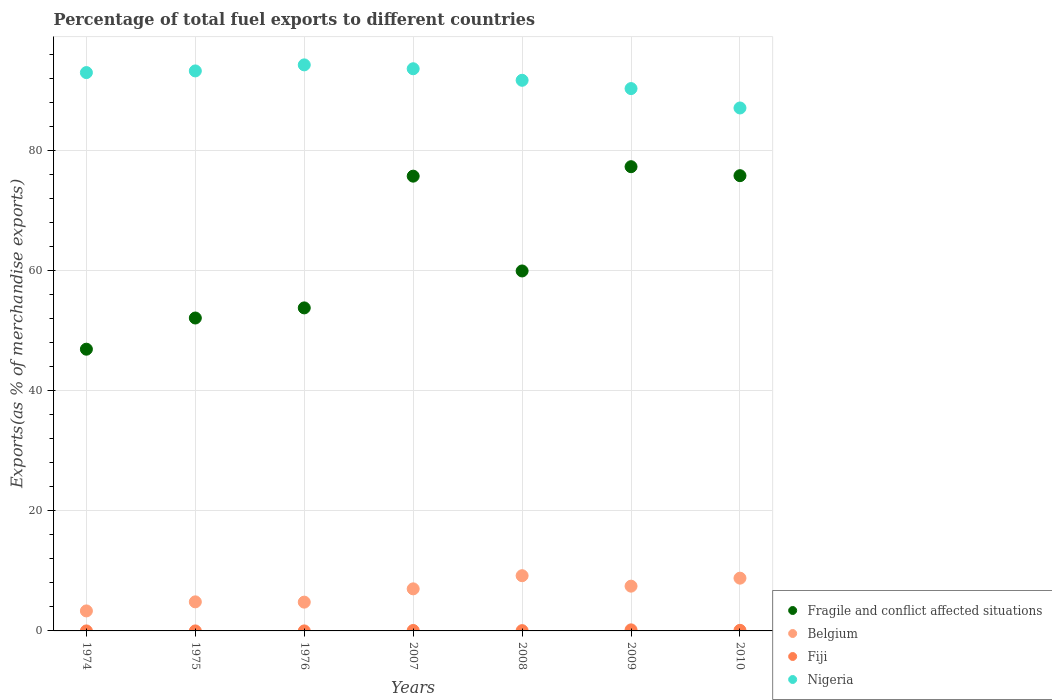How many different coloured dotlines are there?
Provide a short and direct response. 4. Is the number of dotlines equal to the number of legend labels?
Keep it short and to the point. Yes. What is the percentage of exports to different countries in Fragile and conflict affected situations in 2008?
Make the answer very short. 59.98. Across all years, what is the maximum percentage of exports to different countries in Nigeria?
Your response must be concise. 94.31. Across all years, what is the minimum percentage of exports to different countries in Belgium?
Provide a succinct answer. 3.33. In which year was the percentage of exports to different countries in Nigeria maximum?
Your response must be concise. 1976. In which year was the percentage of exports to different countries in Belgium minimum?
Ensure brevity in your answer.  1974. What is the total percentage of exports to different countries in Belgium in the graph?
Your answer should be compact. 45.43. What is the difference between the percentage of exports to different countries in Fiji in 2007 and that in 2008?
Your answer should be compact. 0.03. What is the difference between the percentage of exports to different countries in Fiji in 2007 and the percentage of exports to different countries in Nigeria in 1974?
Your answer should be very brief. -92.95. What is the average percentage of exports to different countries in Fragile and conflict affected situations per year?
Your answer should be compact. 63.12. In the year 2007, what is the difference between the percentage of exports to different countries in Fiji and percentage of exports to different countries in Belgium?
Keep it short and to the point. -6.93. What is the ratio of the percentage of exports to different countries in Nigeria in 1975 to that in 1976?
Provide a succinct answer. 0.99. Is the difference between the percentage of exports to different countries in Fiji in 1976 and 2009 greater than the difference between the percentage of exports to different countries in Belgium in 1976 and 2009?
Ensure brevity in your answer.  Yes. What is the difference between the highest and the second highest percentage of exports to different countries in Fragile and conflict affected situations?
Your answer should be very brief. 1.5. What is the difference between the highest and the lowest percentage of exports to different countries in Nigeria?
Offer a very short reply. 7.18. Is it the case that in every year, the sum of the percentage of exports to different countries in Fiji and percentage of exports to different countries in Belgium  is greater than the percentage of exports to different countries in Nigeria?
Your response must be concise. No. Does the percentage of exports to different countries in Fiji monotonically increase over the years?
Your response must be concise. No. Is the percentage of exports to different countries in Nigeria strictly greater than the percentage of exports to different countries in Fiji over the years?
Your response must be concise. Yes. How many dotlines are there?
Provide a succinct answer. 4. How many years are there in the graph?
Provide a short and direct response. 7. What is the difference between two consecutive major ticks on the Y-axis?
Your answer should be compact. 20. Are the values on the major ticks of Y-axis written in scientific E-notation?
Keep it short and to the point. No. Does the graph contain grids?
Ensure brevity in your answer.  Yes. What is the title of the graph?
Provide a short and direct response. Percentage of total fuel exports to different countries. What is the label or title of the Y-axis?
Your answer should be very brief. Exports(as % of merchandise exports). What is the Exports(as % of merchandise exports) in Fragile and conflict affected situations in 1974?
Your response must be concise. 46.94. What is the Exports(as % of merchandise exports) in Belgium in 1974?
Offer a terse response. 3.33. What is the Exports(as % of merchandise exports) in Fiji in 1974?
Your answer should be very brief. 0. What is the Exports(as % of merchandise exports) in Nigeria in 1974?
Keep it short and to the point. 93.03. What is the Exports(as % of merchandise exports) of Fragile and conflict affected situations in 1975?
Give a very brief answer. 52.14. What is the Exports(as % of merchandise exports) in Belgium in 1975?
Make the answer very short. 4.84. What is the Exports(as % of merchandise exports) of Fiji in 1975?
Provide a short and direct response. 4.37885188442796e-5. What is the Exports(as % of merchandise exports) in Nigeria in 1975?
Your answer should be compact. 93.3. What is the Exports(as % of merchandise exports) of Fragile and conflict affected situations in 1976?
Provide a short and direct response. 53.82. What is the Exports(as % of merchandise exports) of Belgium in 1976?
Your response must be concise. 4.8. What is the Exports(as % of merchandise exports) in Fiji in 1976?
Offer a terse response. 0. What is the Exports(as % of merchandise exports) in Nigeria in 1976?
Provide a short and direct response. 94.31. What is the Exports(as % of merchandise exports) of Fragile and conflict affected situations in 2007?
Keep it short and to the point. 75.77. What is the Exports(as % of merchandise exports) in Belgium in 2007?
Ensure brevity in your answer.  7.01. What is the Exports(as % of merchandise exports) of Fiji in 2007?
Keep it short and to the point. 0.08. What is the Exports(as % of merchandise exports) of Nigeria in 2007?
Offer a terse response. 93.67. What is the Exports(as % of merchandise exports) of Fragile and conflict affected situations in 2008?
Ensure brevity in your answer.  59.98. What is the Exports(as % of merchandise exports) in Belgium in 2008?
Ensure brevity in your answer.  9.2. What is the Exports(as % of merchandise exports) of Fiji in 2008?
Your answer should be very brief. 0.05. What is the Exports(as % of merchandise exports) in Nigeria in 2008?
Your answer should be compact. 91.74. What is the Exports(as % of merchandise exports) in Fragile and conflict affected situations in 2009?
Make the answer very short. 77.35. What is the Exports(as % of merchandise exports) in Belgium in 2009?
Give a very brief answer. 7.46. What is the Exports(as % of merchandise exports) of Fiji in 2009?
Your answer should be compact. 0.18. What is the Exports(as % of merchandise exports) of Nigeria in 2009?
Make the answer very short. 90.36. What is the Exports(as % of merchandise exports) in Fragile and conflict affected situations in 2010?
Your response must be concise. 75.85. What is the Exports(as % of merchandise exports) in Belgium in 2010?
Make the answer very short. 8.79. What is the Exports(as % of merchandise exports) in Fiji in 2010?
Provide a short and direct response. 0.1. What is the Exports(as % of merchandise exports) of Nigeria in 2010?
Give a very brief answer. 87.13. Across all years, what is the maximum Exports(as % of merchandise exports) in Fragile and conflict affected situations?
Offer a very short reply. 77.35. Across all years, what is the maximum Exports(as % of merchandise exports) of Belgium?
Keep it short and to the point. 9.2. Across all years, what is the maximum Exports(as % of merchandise exports) in Fiji?
Offer a terse response. 0.18. Across all years, what is the maximum Exports(as % of merchandise exports) of Nigeria?
Offer a very short reply. 94.31. Across all years, what is the minimum Exports(as % of merchandise exports) in Fragile and conflict affected situations?
Give a very brief answer. 46.94. Across all years, what is the minimum Exports(as % of merchandise exports) in Belgium?
Keep it short and to the point. 3.33. Across all years, what is the minimum Exports(as % of merchandise exports) in Fiji?
Offer a very short reply. 4.37885188442796e-5. Across all years, what is the minimum Exports(as % of merchandise exports) in Nigeria?
Make the answer very short. 87.13. What is the total Exports(as % of merchandise exports) in Fragile and conflict affected situations in the graph?
Provide a succinct answer. 441.84. What is the total Exports(as % of merchandise exports) of Belgium in the graph?
Make the answer very short. 45.43. What is the total Exports(as % of merchandise exports) in Fiji in the graph?
Provide a short and direct response. 0.4. What is the total Exports(as % of merchandise exports) of Nigeria in the graph?
Give a very brief answer. 643.55. What is the difference between the Exports(as % of merchandise exports) of Fragile and conflict affected situations in 1974 and that in 1975?
Your answer should be compact. -5.2. What is the difference between the Exports(as % of merchandise exports) in Belgium in 1974 and that in 1975?
Provide a succinct answer. -1.51. What is the difference between the Exports(as % of merchandise exports) of Fiji in 1974 and that in 1975?
Make the answer very short. 0. What is the difference between the Exports(as % of merchandise exports) of Nigeria in 1974 and that in 1975?
Keep it short and to the point. -0.28. What is the difference between the Exports(as % of merchandise exports) in Fragile and conflict affected situations in 1974 and that in 1976?
Keep it short and to the point. -6.88. What is the difference between the Exports(as % of merchandise exports) in Belgium in 1974 and that in 1976?
Offer a very short reply. -1.46. What is the difference between the Exports(as % of merchandise exports) of Nigeria in 1974 and that in 1976?
Offer a very short reply. -1.28. What is the difference between the Exports(as % of merchandise exports) of Fragile and conflict affected situations in 1974 and that in 2007?
Ensure brevity in your answer.  -28.83. What is the difference between the Exports(as % of merchandise exports) in Belgium in 1974 and that in 2007?
Your answer should be compact. -3.68. What is the difference between the Exports(as % of merchandise exports) of Fiji in 1974 and that in 2007?
Provide a succinct answer. -0.07. What is the difference between the Exports(as % of merchandise exports) of Nigeria in 1974 and that in 2007?
Provide a short and direct response. -0.64. What is the difference between the Exports(as % of merchandise exports) in Fragile and conflict affected situations in 1974 and that in 2008?
Offer a very short reply. -13.04. What is the difference between the Exports(as % of merchandise exports) of Belgium in 1974 and that in 2008?
Your response must be concise. -5.87. What is the difference between the Exports(as % of merchandise exports) of Fiji in 1974 and that in 2008?
Ensure brevity in your answer.  -0.05. What is the difference between the Exports(as % of merchandise exports) in Nigeria in 1974 and that in 2008?
Your answer should be compact. 1.28. What is the difference between the Exports(as % of merchandise exports) of Fragile and conflict affected situations in 1974 and that in 2009?
Your answer should be compact. -30.41. What is the difference between the Exports(as % of merchandise exports) of Belgium in 1974 and that in 2009?
Your response must be concise. -4.12. What is the difference between the Exports(as % of merchandise exports) of Fiji in 1974 and that in 2009?
Your answer should be compact. -0.18. What is the difference between the Exports(as % of merchandise exports) in Nigeria in 1974 and that in 2009?
Make the answer very short. 2.66. What is the difference between the Exports(as % of merchandise exports) of Fragile and conflict affected situations in 1974 and that in 2010?
Provide a succinct answer. -28.91. What is the difference between the Exports(as % of merchandise exports) of Belgium in 1974 and that in 2010?
Give a very brief answer. -5.46. What is the difference between the Exports(as % of merchandise exports) in Fiji in 1974 and that in 2010?
Your answer should be compact. -0.1. What is the difference between the Exports(as % of merchandise exports) of Nigeria in 1974 and that in 2010?
Your answer should be compact. 5.89. What is the difference between the Exports(as % of merchandise exports) of Fragile and conflict affected situations in 1975 and that in 1976?
Offer a terse response. -1.68. What is the difference between the Exports(as % of merchandise exports) of Belgium in 1975 and that in 1976?
Provide a short and direct response. 0.05. What is the difference between the Exports(as % of merchandise exports) of Fiji in 1975 and that in 1976?
Your response must be concise. -0. What is the difference between the Exports(as % of merchandise exports) in Nigeria in 1975 and that in 1976?
Your answer should be very brief. -1.01. What is the difference between the Exports(as % of merchandise exports) in Fragile and conflict affected situations in 1975 and that in 2007?
Ensure brevity in your answer.  -23.63. What is the difference between the Exports(as % of merchandise exports) of Belgium in 1975 and that in 2007?
Your response must be concise. -2.17. What is the difference between the Exports(as % of merchandise exports) in Fiji in 1975 and that in 2007?
Your response must be concise. -0.08. What is the difference between the Exports(as % of merchandise exports) in Nigeria in 1975 and that in 2007?
Provide a short and direct response. -0.36. What is the difference between the Exports(as % of merchandise exports) in Fragile and conflict affected situations in 1975 and that in 2008?
Offer a terse response. -7.84. What is the difference between the Exports(as % of merchandise exports) in Belgium in 1975 and that in 2008?
Ensure brevity in your answer.  -4.36. What is the difference between the Exports(as % of merchandise exports) of Fiji in 1975 and that in 2008?
Your response must be concise. -0.05. What is the difference between the Exports(as % of merchandise exports) in Nigeria in 1975 and that in 2008?
Your response must be concise. 1.56. What is the difference between the Exports(as % of merchandise exports) in Fragile and conflict affected situations in 1975 and that in 2009?
Offer a very short reply. -25.21. What is the difference between the Exports(as % of merchandise exports) in Belgium in 1975 and that in 2009?
Provide a succinct answer. -2.62. What is the difference between the Exports(as % of merchandise exports) in Fiji in 1975 and that in 2009?
Your response must be concise. -0.18. What is the difference between the Exports(as % of merchandise exports) of Nigeria in 1975 and that in 2009?
Provide a succinct answer. 2.94. What is the difference between the Exports(as % of merchandise exports) in Fragile and conflict affected situations in 1975 and that in 2010?
Ensure brevity in your answer.  -23.72. What is the difference between the Exports(as % of merchandise exports) of Belgium in 1975 and that in 2010?
Provide a short and direct response. -3.95. What is the difference between the Exports(as % of merchandise exports) in Fiji in 1975 and that in 2010?
Keep it short and to the point. -0.1. What is the difference between the Exports(as % of merchandise exports) in Nigeria in 1975 and that in 2010?
Your answer should be compact. 6.17. What is the difference between the Exports(as % of merchandise exports) in Fragile and conflict affected situations in 1976 and that in 2007?
Give a very brief answer. -21.95. What is the difference between the Exports(as % of merchandise exports) of Belgium in 1976 and that in 2007?
Make the answer very short. -2.21. What is the difference between the Exports(as % of merchandise exports) of Fiji in 1976 and that in 2007?
Make the answer very short. -0.07. What is the difference between the Exports(as % of merchandise exports) of Nigeria in 1976 and that in 2007?
Provide a short and direct response. 0.65. What is the difference between the Exports(as % of merchandise exports) in Fragile and conflict affected situations in 1976 and that in 2008?
Offer a very short reply. -6.16. What is the difference between the Exports(as % of merchandise exports) in Belgium in 1976 and that in 2008?
Ensure brevity in your answer.  -4.4. What is the difference between the Exports(as % of merchandise exports) of Fiji in 1976 and that in 2008?
Give a very brief answer. -0.05. What is the difference between the Exports(as % of merchandise exports) in Nigeria in 1976 and that in 2008?
Provide a succinct answer. 2.57. What is the difference between the Exports(as % of merchandise exports) of Fragile and conflict affected situations in 1976 and that in 2009?
Offer a terse response. -23.53. What is the difference between the Exports(as % of merchandise exports) in Belgium in 1976 and that in 2009?
Offer a terse response. -2.66. What is the difference between the Exports(as % of merchandise exports) of Fiji in 1976 and that in 2009?
Make the answer very short. -0.18. What is the difference between the Exports(as % of merchandise exports) of Nigeria in 1976 and that in 2009?
Keep it short and to the point. 3.95. What is the difference between the Exports(as % of merchandise exports) in Fragile and conflict affected situations in 1976 and that in 2010?
Ensure brevity in your answer.  -22.03. What is the difference between the Exports(as % of merchandise exports) of Belgium in 1976 and that in 2010?
Ensure brevity in your answer.  -4. What is the difference between the Exports(as % of merchandise exports) of Fiji in 1976 and that in 2010?
Make the answer very short. -0.1. What is the difference between the Exports(as % of merchandise exports) of Nigeria in 1976 and that in 2010?
Provide a succinct answer. 7.18. What is the difference between the Exports(as % of merchandise exports) in Fragile and conflict affected situations in 2007 and that in 2008?
Keep it short and to the point. 15.8. What is the difference between the Exports(as % of merchandise exports) in Belgium in 2007 and that in 2008?
Provide a short and direct response. -2.19. What is the difference between the Exports(as % of merchandise exports) in Fiji in 2007 and that in 2008?
Make the answer very short. 0.03. What is the difference between the Exports(as % of merchandise exports) of Nigeria in 2007 and that in 2008?
Your answer should be very brief. 1.92. What is the difference between the Exports(as % of merchandise exports) of Fragile and conflict affected situations in 2007 and that in 2009?
Ensure brevity in your answer.  -1.58. What is the difference between the Exports(as % of merchandise exports) in Belgium in 2007 and that in 2009?
Provide a succinct answer. -0.45. What is the difference between the Exports(as % of merchandise exports) in Fiji in 2007 and that in 2009?
Your answer should be very brief. -0.1. What is the difference between the Exports(as % of merchandise exports) in Nigeria in 2007 and that in 2009?
Your response must be concise. 3.3. What is the difference between the Exports(as % of merchandise exports) of Fragile and conflict affected situations in 2007 and that in 2010?
Your answer should be compact. -0.08. What is the difference between the Exports(as % of merchandise exports) in Belgium in 2007 and that in 2010?
Offer a very short reply. -1.78. What is the difference between the Exports(as % of merchandise exports) of Fiji in 2007 and that in 2010?
Give a very brief answer. -0.02. What is the difference between the Exports(as % of merchandise exports) of Nigeria in 2007 and that in 2010?
Provide a short and direct response. 6.53. What is the difference between the Exports(as % of merchandise exports) of Fragile and conflict affected situations in 2008 and that in 2009?
Your answer should be compact. -17.37. What is the difference between the Exports(as % of merchandise exports) of Belgium in 2008 and that in 2009?
Offer a terse response. 1.74. What is the difference between the Exports(as % of merchandise exports) of Fiji in 2008 and that in 2009?
Offer a very short reply. -0.13. What is the difference between the Exports(as % of merchandise exports) of Nigeria in 2008 and that in 2009?
Keep it short and to the point. 1.38. What is the difference between the Exports(as % of merchandise exports) in Fragile and conflict affected situations in 2008 and that in 2010?
Ensure brevity in your answer.  -15.88. What is the difference between the Exports(as % of merchandise exports) of Belgium in 2008 and that in 2010?
Make the answer very short. 0.41. What is the difference between the Exports(as % of merchandise exports) of Fiji in 2008 and that in 2010?
Your answer should be compact. -0.05. What is the difference between the Exports(as % of merchandise exports) in Nigeria in 2008 and that in 2010?
Offer a terse response. 4.61. What is the difference between the Exports(as % of merchandise exports) of Fragile and conflict affected situations in 2009 and that in 2010?
Make the answer very short. 1.5. What is the difference between the Exports(as % of merchandise exports) in Belgium in 2009 and that in 2010?
Make the answer very short. -1.33. What is the difference between the Exports(as % of merchandise exports) in Fiji in 2009 and that in 2010?
Provide a succinct answer. 0.08. What is the difference between the Exports(as % of merchandise exports) of Nigeria in 2009 and that in 2010?
Give a very brief answer. 3.23. What is the difference between the Exports(as % of merchandise exports) in Fragile and conflict affected situations in 1974 and the Exports(as % of merchandise exports) in Belgium in 1975?
Your response must be concise. 42.1. What is the difference between the Exports(as % of merchandise exports) of Fragile and conflict affected situations in 1974 and the Exports(as % of merchandise exports) of Fiji in 1975?
Offer a very short reply. 46.94. What is the difference between the Exports(as % of merchandise exports) of Fragile and conflict affected situations in 1974 and the Exports(as % of merchandise exports) of Nigeria in 1975?
Provide a succinct answer. -46.36. What is the difference between the Exports(as % of merchandise exports) of Belgium in 1974 and the Exports(as % of merchandise exports) of Fiji in 1975?
Make the answer very short. 3.33. What is the difference between the Exports(as % of merchandise exports) of Belgium in 1974 and the Exports(as % of merchandise exports) of Nigeria in 1975?
Provide a succinct answer. -89.97. What is the difference between the Exports(as % of merchandise exports) of Fiji in 1974 and the Exports(as % of merchandise exports) of Nigeria in 1975?
Your answer should be very brief. -93.3. What is the difference between the Exports(as % of merchandise exports) of Fragile and conflict affected situations in 1974 and the Exports(as % of merchandise exports) of Belgium in 1976?
Your response must be concise. 42.14. What is the difference between the Exports(as % of merchandise exports) of Fragile and conflict affected situations in 1974 and the Exports(as % of merchandise exports) of Fiji in 1976?
Offer a terse response. 46.94. What is the difference between the Exports(as % of merchandise exports) of Fragile and conflict affected situations in 1974 and the Exports(as % of merchandise exports) of Nigeria in 1976?
Keep it short and to the point. -47.37. What is the difference between the Exports(as % of merchandise exports) of Belgium in 1974 and the Exports(as % of merchandise exports) of Fiji in 1976?
Provide a short and direct response. 3.33. What is the difference between the Exports(as % of merchandise exports) of Belgium in 1974 and the Exports(as % of merchandise exports) of Nigeria in 1976?
Offer a terse response. -90.98. What is the difference between the Exports(as % of merchandise exports) of Fiji in 1974 and the Exports(as % of merchandise exports) of Nigeria in 1976?
Offer a terse response. -94.31. What is the difference between the Exports(as % of merchandise exports) of Fragile and conflict affected situations in 1974 and the Exports(as % of merchandise exports) of Belgium in 2007?
Provide a short and direct response. 39.93. What is the difference between the Exports(as % of merchandise exports) of Fragile and conflict affected situations in 1974 and the Exports(as % of merchandise exports) of Fiji in 2007?
Make the answer very short. 46.86. What is the difference between the Exports(as % of merchandise exports) in Fragile and conflict affected situations in 1974 and the Exports(as % of merchandise exports) in Nigeria in 2007?
Your answer should be very brief. -46.73. What is the difference between the Exports(as % of merchandise exports) in Belgium in 1974 and the Exports(as % of merchandise exports) in Fiji in 2007?
Ensure brevity in your answer.  3.26. What is the difference between the Exports(as % of merchandise exports) of Belgium in 1974 and the Exports(as % of merchandise exports) of Nigeria in 2007?
Keep it short and to the point. -90.33. What is the difference between the Exports(as % of merchandise exports) of Fiji in 1974 and the Exports(as % of merchandise exports) of Nigeria in 2007?
Your response must be concise. -93.67. What is the difference between the Exports(as % of merchandise exports) of Fragile and conflict affected situations in 1974 and the Exports(as % of merchandise exports) of Belgium in 2008?
Offer a terse response. 37.74. What is the difference between the Exports(as % of merchandise exports) of Fragile and conflict affected situations in 1974 and the Exports(as % of merchandise exports) of Fiji in 2008?
Your answer should be compact. 46.89. What is the difference between the Exports(as % of merchandise exports) in Fragile and conflict affected situations in 1974 and the Exports(as % of merchandise exports) in Nigeria in 2008?
Ensure brevity in your answer.  -44.8. What is the difference between the Exports(as % of merchandise exports) in Belgium in 1974 and the Exports(as % of merchandise exports) in Fiji in 2008?
Your response must be concise. 3.28. What is the difference between the Exports(as % of merchandise exports) of Belgium in 1974 and the Exports(as % of merchandise exports) of Nigeria in 2008?
Provide a succinct answer. -88.41. What is the difference between the Exports(as % of merchandise exports) of Fiji in 1974 and the Exports(as % of merchandise exports) of Nigeria in 2008?
Make the answer very short. -91.74. What is the difference between the Exports(as % of merchandise exports) in Fragile and conflict affected situations in 1974 and the Exports(as % of merchandise exports) in Belgium in 2009?
Make the answer very short. 39.48. What is the difference between the Exports(as % of merchandise exports) of Fragile and conflict affected situations in 1974 and the Exports(as % of merchandise exports) of Fiji in 2009?
Your answer should be compact. 46.76. What is the difference between the Exports(as % of merchandise exports) of Fragile and conflict affected situations in 1974 and the Exports(as % of merchandise exports) of Nigeria in 2009?
Give a very brief answer. -43.42. What is the difference between the Exports(as % of merchandise exports) of Belgium in 1974 and the Exports(as % of merchandise exports) of Fiji in 2009?
Keep it short and to the point. 3.16. What is the difference between the Exports(as % of merchandise exports) of Belgium in 1974 and the Exports(as % of merchandise exports) of Nigeria in 2009?
Your answer should be compact. -87.03. What is the difference between the Exports(as % of merchandise exports) in Fiji in 1974 and the Exports(as % of merchandise exports) in Nigeria in 2009?
Provide a succinct answer. -90.36. What is the difference between the Exports(as % of merchandise exports) in Fragile and conflict affected situations in 1974 and the Exports(as % of merchandise exports) in Belgium in 2010?
Make the answer very short. 38.15. What is the difference between the Exports(as % of merchandise exports) in Fragile and conflict affected situations in 1974 and the Exports(as % of merchandise exports) in Fiji in 2010?
Offer a very short reply. 46.84. What is the difference between the Exports(as % of merchandise exports) of Fragile and conflict affected situations in 1974 and the Exports(as % of merchandise exports) of Nigeria in 2010?
Your answer should be very brief. -40.19. What is the difference between the Exports(as % of merchandise exports) in Belgium in 1974 and the Exports(as % of merchandise exports) in Fiji in 2010?
Provide a succinct answer. 3.24. What is the difference between the Exports(as % of merchandise exports) of Belgium in 1974 and the Exports(as % of merchandise exports) of Nigeria in 2010?
Your answer should be very brief. -83.8. What is the difference between the Exports(as % of merchandise exports) in Fiji in 1974 and the Exports(as % of merchandise exports) in Nigeria in 2010?
Give a very brief answer. -87.13. What is the difference between the Exports(as % of merchandise exports) of Fragile and conflict affected situations in 1975 and the Exports(as % of merchandise exports) of Belgium in 1976?
Your response must be concise. 47.34. What is the difference between the Exports(as % of merchandise exports) in Fragile and conflict affected situations in 1975 and the Exports(as % of merchandise exports) in Fiji in 1976?
Offer a very short reply. 52.13. What is the difference between the Exports(as % of merchandise exports) in Fragile and conflict affected situations in 1975 and the Exports(as % of merchandise exports) in Nigeria in 1976?
Provide a succinct answer. -42.18. What is the difference between the Exports(as % of merchandise exports) of Belgium in 1975 and the Exports(as % of merchandise exports) of Fiji in 1976?
Give a very brief answer. 4.84. What is the difference between the Exports(as % of merchandise exports) in Belgium in 1975 and the Exports(as % of merchandise exports) in Nigeria in 1976?
Provide a short and direct response. -89.47. What is the difference between the Exports(as % of merchandise exports) of Fiji in 1975 and the Exports(as % of merchandise exports) of Nigeria in 1976?
Give a very brief answer. -94.31. What is the difference between the Exports(as % of merchandise exports) of Fragile and conflict affected situations in 1975 and the Exports(as % of merchandise exports) of Belgium in 2007?
Provide a short and direct response. 45.13. What is the difference between the Exports(as % of merchandise exports) in Fragile and conflict affected situations in 1975 and the Exports(as % of merchandise exports) in Fiji in 2007?
Make the answer very short. 52.06. What is the difference between the Exports(as % of merchandise exports) in Fragile and conflict affected situations in 1975 and the Exports(as % of merchandise exports) in Nigeria in 2007?
Provide a short and direct response. -41.53. What is the difference between the Exports(as % of merchandise exports) in Belgium in 1975 and the Exports(as % of merchandise exports) in Fiji in 2007?
Provide a short and direct response. 4.77. What is the difference between the Exports(as % of merchandise exports) in Belgium in 1975 and the Exports(as % of merchandise exports) in Nigeria in 2007?
Keep it short and to the point. -88.82. What is the difference between the Exports(as % of merchandise exports) of Fiji in 1975 and the Exports(as % of merchandise exports) of Nigeria in 2007?
Provide a succinct answer. -93.67. What is the difference between the Exports(as % of merchandise exports) of Fragile and conflict affected situations in 1975 and the Exports(as % of merchandise exports) of Belgium in 2008?
Give a very brief answer. 42.93. What is the difference between the Exports(as % of merchandise exports) of Fragile and conflict affected situations in 1975 and the Exports(as % of merchandise exports) of Fiji in 2008?
Keep it short and to the point. 52.09. What is the difference between the Exports(as % of merchandise exports) in Fragile and conflict affected situations in 1975 and the Exports(as % of merchandise exports) in Nigeria in 2008?
Offer a very short reply. -39.61. What is the difference between the Exports(as % of merchandise exports) in Belgium in 1975 and the Exports(as % of merchandise exports) in Fiji in 2008?
Keep it short and to the point. 4.79. What is the difference between the Exports(as % of merchandise exports) of Belgium in 1975 and the Exports(as % of merchandise exports) of Nigeria in 2008?
Ensure brevity in your answer.  -86.9. What is the difference between the Exports(as % of merchandise exports) in Fiji in 1975 and the Exports(as % of merchandise exports) in Nigeria in 2008?
Your response must be concise. -91.74. What is the difference between the Exports(as % of merchandise exports) in Fragile and conflict affected situations in 1975 and the Exports(as % of merchandise exports) in Belgium in 2009?
Make the answer very short. 44.68. What is the difference between the Exports(as % of merchandise exports) of Fragile and conflict affected situations in 1975 and the Exports(as % of merchandise exports) of Fiji in 2009?
Offer a very short reply. 51.96. What is the difference between the Exports(as % of merchandise exports) of Fragile and conflict affected situations in 1975 and the Exports(as % of merchandise exports) of Nigeria in 2009?
Your response must be concise. -38.23. What is the difference between the Exports(as % of merchandise exports) in Belgium in 1975 and the Exports(as % of merchandise exports) in Fiji in 2009?
Keep it short and to the point. 4.67. What is the difference between the Exports(as % of merchandise exports) in Belgium in 1975 and the Exports(as % of merchandise exports) in Nigeria in 2009?
Provide a succinct answer. -85.52. What is the difference between the Exports(as % of merchandise exports) of Fiji in 1975 and the Exports(as % of merchandise exports) of Nigeria in 2009?
Your answer should be very brief. -90.36. What is the difference between the Exports(as % of merchandise exports) in Fragile and conflict affected situations in 1975 and the Exports(as % of merchandise exports) in Belgium in 2010?
Your answer should be compact. 43.34. What is the difference between the Exports(as % of merchandise exports) of Fragile and conflict affected situations in 1975 and the Exports(as % of merchandise exports) of Fiji in 2010?
Offer a terse response. 52.04. What is the difference between the Exports(as % of merchandise exports) of Fragile and conflict affected situations in 1975 and the Exports(as % of merchandise exports) of Nigeria in 2010?
Offer a very short reply. -35. What is the difference between the Exports(as % of merchandise exports) in Belgium in 1975 and the Exports(as % of merchandise exports) in Fiji in 2010?
Provide a short and direct response. 4.74. What is the difference between the Exports(as % of merchandise exports) of Belgium in 1975 and the Exports(as % of merchandise exports) of Nigeria in 2010?
Your answer should be compact. -82.29. What is the difference between the Exports(as % of merchandise exports) in Fiji in 1975 and the Exports(as % of merchandise exports) in Nigeria in 2010?
Make the answer very short. -87.13. What is the difference between the Exports(as % of merchandise exports) of Fragile and conflict affected situations in 1976 and the Exports(as % of merchandise exports) of Belgium in 2007?
Your answer should be compact. 46.81. What is the difference between the Exports(as % of merchandise exports) of Fragile and conflict affected situations in 1976 and the Exports(as % of merchandise exports) of Fiji in 2007?
Offer a terse response. 53.74. What is the difference between the Exports(as % of merchandise exports) in Fragile and conflict affected situations in 1976 and the Exports(as % of merchandise exports) in Nigeria in 2007?
Give a very brief answer. -39.85. What is the difference between the Exports(as % of merchandise exports) of Belgium in 1976 and the Exports(as % of merchandise exports) of Fiji in 2007?
Your answer should be very brief. 4.72. What is the difference between the Exports(as % of merchandise exports) of Belgium in 1976 and the Exports(as % of merchandise exports) of Nigeria in 2007?
Offer a terse response. -88.87. What is the difference between the Exports(as % of merchandise exports) in Fiji in 1976 and the Exports(as % of merchandise exports) in Nigeria in 2007?
Your response must be concise. -93.67. What is the difference between the Exports(as % of merchandise exports) of Fragile and conflict affected situations in 1976 and the Exports(as % of merchandise exports) of Belgium in 2008?
Offer a terse response. 44.62. What is the difference between the Exports(as % of merchandise exports) of Fragile and conflict affected situations in 1976 and the Exports(as % of merchandise exports) of Fiji in 2008?
Make the answer very short. 53.77. What is the difference between the Exports(as % of merchandise exports) of Fragile and conflict affected situations in 1976 and the Exports(as % of merchandise exports) of Nigeria in 2008?
Your answer should be compact. -37.92. What is the difference between the Exports(as % of merchandise exports) of Belgium in 1976 and the Exports(as % of merchandise exports) of Fiji in 2008?
Offer a terse response. 4.75. What is the difference between the Exports(as % of merchandise exports) of Belgium in 1976 and the Exports(as % of merchandise exports) of Nigeria in 2008?
Keep it short and to the point. -86.95. What is the difference between the Exports(as % of merchandise exports) of Fiji in 1976 and the Exports(as % of merchandise exports) of Nigeria in 2008?
Give a very brief answer. -91.74. What is the difference between the Exports(as % of merchandise exports) in Fragile and conflict affected situations in 1976 and the Exports(as % of merchandise exports) in Belgium in 2009?
Keep it short and to the point. 46.36. What is the difference between the Exports(as % of merchandise exports) of Fragile and conflict affected situations in 1976 and the Exports(as % of merchandise exports) of Fiji in 2009?
Offer a very short reply. 53.64. What is the difference between the Exports(as % of merchandise exports) of Fragile and conflict affected situations in 1976 and the Exports(as % of merchandise exports) of Nigeria in 2009?
Make the answer very short. -36.54. What is the difference between the Exports(as % of merchandise exports) in Belgium in 1976 and the Exports(as % of merchandise exports) in Fiji in 2009?
Provide a short and direct response. 4.62. What is the difference between the Exports(as % of merchandise exports) of Belgium in 1976 and the Exports(as % of merchandise exports) of Nigeria in 2009?
Make the answer very short. -85.57. What is the difference between the Exports(as % of merchandise exports) in Fiji in 1976 and the Exports(as % of merchandise exports) in Nigeria in 2009?
Your answer should be very brief. -90.36. What is the difference between the Exports(as % of merchandise exports) in Fragile and conflict affected situations in 1976 and the Exports(as % of merchandise exports) in Belgium in 2010?
Offer a terse response. 45.03. What is the difference between the Exports(as % of merchandise exports) in Fragile and conflict affected situations in 1976 and the Exports(as % of merchandise exports) in Fiji in 2010?
Ensure brevity in your answer.  53.72. What is the difference between the Exports(as % of merchandise exports) of Fragile and conflict affected situations in 1976 and the Exports(as % of merchandise exports) of Nigeria in 2010?
Give a very brief answer. -33.31. What is the difference between the Exports(as % of merchandise exports) of Belgium in 1976 and the Exports(as % of merchandise exports) of Fiji in 2010?
Give a very brief answer. 4.7. What is the difference between the Exports(as % of merchandise exports) in Belgium in 1976 and the Exports(as % of merchandise exports) in Nigeria in 2010?
Your response must be concise. -82.34. What is the difference between the Exports(as % of merchandise exports) of Fiji in 1976 and the Exports(as % of merchandise exports) of Nigeria in 2010?
Ensure brevity in your answer.  -87.13. What is the difference between the Exports(as % of merchandise exports) in Fragile and conflict affected situations in 2007 and the Exports(as % of merchandise exports) in Belgium in 2008?
Your response must be concise. 66.57. What is the difference between the Exports(as % of merchandise exports) of Fragile and conflict affected situations in 2007 and the Exports(as % of merchandise exports) of Fiji in 2008?
Your answer should be very brief. 75.72. What is the difference between the Exports(as % of merchandise exports) of Fragile and conflict affected situations in 2007 and the Exports(as % of merchandise exports) of Nigeria in 2008?
Make the answer very short. -15.97. What is the difference between the Exports(as % of merchandise exports) in Belgium in 2007 and the Exports(as % of merchandise exports) in Fiji in 2008?
Make the answer very short. 6.96. What is the difference between the Exports(as % of merchandise exports) of Belgium in 2007 and the Exports(as % of merchandise exports) of Nigeria in 2008?
Keep it short and to the point. -84.73. What is the difference between the Exports(as % of merchandise exports) of Fiji in 2007 and the Exports(as % of merchandise exports) of Nigeria in 2008?
Provide a succinct answer. -91.67. What is the difference between the Exports(as % of merchandise exports) of Fragile and conflict affected situations in 2007 and the Exports(as % of merchandise exports) of Belgium in 2009?
Give a very brief answer. 68.31. What is the difference between the Exports(as % of merchandise exports) in Fragile and conflict affected situations in 2007 and the Exports(as % of merchandise exports) in Fiji in 2009?
Provide a succinct answer. 75.59. What is the difference between the Exports(as % of merchandise exports) in Fragile and conflict affected situations in 2007 and the Exports(as % of merchandise exports) in Nigeria in 2009?
Offer a very short reply. -14.59. What is the difference between the Exports(as % of merchandise exports) of Belgium in 2007 and the Exports(as % of merchandise exports) of Fiji in 2009?
Provide a succinct answer. 6.83. What is the difference between the Exports(as % of merchandise exports) of Belgium in 2007 and the Exports(as % of merchandise exports) of Nigeria in 2009?
Make the answer very short. -83.35. What is the difference between the Exports(as % of merchandise exports) of Fiji in 2007 and the Exports(as % of merchandise exports) of Nigeria in 2009?
Your response must be concise. -90.29. What is the difference between the Exports(as % of merchandise exports) in Fragile and conflict affected situations in 2007 and the Exports(as % of merchandise exports) in Belgium in 2010?
Make the answer very short. 66.98. What is the difference between the Exports(as % of merchandise exports) in Fragile and conflict affected situations in 2007 and the Exports(as % of merchandise exports) in Fiji in 2010?
Ensure brevity in your answer.  75.67. What is the difference between the Exports(as % of merchandise exports) of Fragile and conflict affected situations in 2007 and the Exports(as % of merchandise exports) of Nigeria in 2010?
Provide a short and direct response. -11.36. What is the difference between the Exports(as % of merchandise exports) of Belgium in 2007 and the Exports(as % of merchandise exports) of Fiji in 2010?
Make the answer very short. 6.91. What is the difference between the Exports(as % of merchandise exports) of Belgium in 2007 and the Exports(as % of merchandise exports) of Nigeria in 2010?
Provide a succinct answer. -80.12. What is the difference between the Exports(as % of merchandise exports) of Fiji in 2007 and the Exports(as % of merchandise exports) of Nigeria in 2010?
Your answer should be very brief. -87.06. What is the difference between the Exports(as % of merchandise exports) in Fragile and conflict affected situations in 2008 and the Exports(as % of merchandise exports) in Belgium in 2009?
Ensure brevity in your answer.  52.52. What is the difference between the Exports(as % of merchandise exports) of Fragile and conflict affected situations in 2008 and the Exports(as % of merchandise exports) of Fiji in 2009?
Your response must be concise. 59.8. What is the difference between the Exports(as % of merchandise exports) of Fragile and conflict affected situations in 2008 and the Exports(as % of merchandise exports) of Nigeria in 2009?
Offer a terse response. -30.39. What is the difference between the Exports(as % of merchandise exports) in Belgium in 2008 and the Exports(as % of merchandise exports) in Fiji in 2009?
Your answer should be compact. 9.02. What is the difference between the Exports(as % of merchandise exports) of Belgium in 2008 and the Exports(as % of merchandise exports) of Nigeria in 2009?
Keep it short and to the point. -81.16. What is the difference between the Exports(as % of merchandise exports) in Fiji in 2008 and the Exports(as % of merchandise exports) in Nigeria in 2009?
Keep it short and to the point. -90.31. What is the difference between the Exports(as % of merchandise exports) in Fragile and conflict affected situations in 2008 and the Exports(as % of merchandise exports) in Belgium in 2010?
Give a very brief answer. 51.18. What is the difference between the Exports(as % of merchandise exports) of Fragile and conflict affected situations in 2008 and the Exports(as % of merchandise exports) of Fiji in 2010?
Ensure brevity in your answer.  59.88. What is the difference between the Exports(as % of merchandise exports) of Fragile and conflict affected situations in 2008 and the Exports(as % of merchandise exports) of Nigeria in 2010?
Ensure brevity in your answer.  -27.16. What is the difference between the Exports(as % of merchandise exports) in Belgium in 2008 and the Exports(as % of merchandise exports) in Fiji in 2010?
Provide a short and direct response. 9.1. What is the difference between the Exports(as % of merchandise exports) in Belgium in 2008 and the Exports(as % of merchandise exports) in Nigeria in 2010?
Provide a succinct answer. -77.93. What is the difference between the Exports(as % of merchandise exports) of Fiji in 2008 and the Exports(as % of merchandise exports) of Nigeria in 2010?
Offer a very short reply. -87.08. What is the difference between the Exports(as % of merchandise exports) in Fragile and conflict affected situations in 2009 and the Exports(as % of merchandise exports) in Belgium in 2010?
Ensure brevity in your answer.  68.56. What is the difference between the Exports(as % of merchandise exports) of Fragile and conflict affected situations in 2009 and the Exports(as % of merchandise exports) of Fiji in 2010?
Provide a short and direct response. 77.25. What is the difference between the Exports(as % of merchandise exports) in Fragile and conflict affected situations in 2009 and the Exports(as % of merchandise exports) in Nigeria in 2010?
Your answer should be very brief. -9.78. What is the difference between the Exports(as % of merchandise exports) of Belgium in 2009 and the Exports(as % of merchandise exports) of Fiji in 2010?
Offer a very short reply. 7.36. What is the difference between the Exports(as % of merchandise exports) in Belgium in 2009 and the Exports(as % of merchandise exports) in Nigeria in 2010?
Offer a very short reply. -79.67. What is the difference between the Exports(as % of merchandise exports) of Fiji in 2009 and the Exports(as % of merchandise exports) of Nigeria in 2010?
Give a very brief answer. -86.96. What is the average Exports(as % of merchandise exports) in Fragile and conflict affected situations per year?
Your response must be concise. 63.12. What is the average Exports(as % of merchandise exports) of Belgium per year?
Provide a succinct answer. 6.49. What is the average Exports(as % of merchandise exports) in Fiji per year?
Provide a short and direct response. 0.06. What is the average Exports(as % of merchandise exports) in Nigeria per year?
Provide a succinct answer. 91.94. In the year 1974, what is the difference between the Exports(as % of merchandise exports) in Fragile and conflict affected situations and Exports(as % of merchandise exports) in Belgium?
Make the answer very short. 43.61. In the year 1974, what is the difference between the Exports(as % of merchandise exports) of Fragile and conflict affected situations and Exports(as % of merchandise exports) of Fiji?
Your answer should be very brief. 46.94. In the year 1974, what is the difference between the Exports(as % of merchandise exports) in Fragile and conflict affected situations and Exports(as % of merchandise exports) in Nigeria?
Your response must be concise. -46.09. In the year 1974, what is the difference between the Exports(as % of merchandise exports) in Belgium and Exports(as % of merchandise exports) in Fiji?
Provide a succinct answer. 3.33. In the year 1974, what is the difference between the Exports(as % of merchandise exports) in Belgium and Exports(as % of merchandise exports) in Nigeria?
Your answer should be very brief. -89.69. In the year 1974, what is the difference between the Exports(as % of merchandise exports) in Fiji and Exports(as % of merchandise exports) in Nigeria?
Make the answer very short. -93.03. In the year 1975, what is the difference between the Exports(as % of merchandise exports) of Fragile and conflict affected situations and Exports(as % of merchandise exports) of Belgium?
Give a very brief answer. 47.29. In the year 1975, what is the difference between the Exports(as % of merchandise exports) in Fragile and conflict affected situations and Exports(as % of merchandise exports) in Fiji?
Ensure brevity in your answer.  52.14. In the year 1975, what is the difference between the Exports(as % of merchandise exports) in Fragile and conflict affected situations and Exports(as % of merchandise exports) in Nigeria?
Ensure brevity in your answer.  -41.17. In the year 1975, what is the difference between the Exports(as % of merchandise exports) in Belgium and Exports(as % of merchandise exports) in Fiji?
Give a very brief answer. 4.84. In the year 1975, what is the difference between the Exports(as % of merchandise exports) of Belgium and Exports(as % of merchandise exports) of Nigeria?
Provide a succinct answer. -88.46. In the year 1975, what is the difference between the Exports(as % of merchandise exports) in Fiji and Exports(as % of merchandise exports) in Nigeria?
Your answer should be very brief. -93.3. In the year 1976, what is the difference between the Exports(as % of merchandise exports) of Fragile and conflict affected situations and Exports(as % of merchandise exports) of Belgium?
Your answer should be compact. 49.02. In the year 1976, what is the difference between the Exports(as % of merchandise exports) of Fragile and conflict affected situations and Exports(as % of merchandise exports) of Fiji?
Make the answer very short. 53.82. In the year 1976, what is the difference between the Exports(as % of merchandise exports) in Fragile and conflict affected situations and Exports(as % of merchandise exports) in Nigeria?
Give a very brief answer. -40.49. In the year 1976, what is the difference between the Exports(as % of merchandise exports) in Belgium and Exports(as % of merchandise exports) in Fiji?
Provide a short and direct response. 4.8. In the year 1976, what is the difference between the Exports(as % of merchandise exports) in Belgium and Exports(as % of merchandise exports) in Nigeria?
Offer a very short reply. -89.52. In the year 1976, what is the difference between the Exports(as % of merchandise exports) in Fiji and Exports(as % of merchandise exports) in Nigeria?
Offer a terse response. -94.31. In the year 2007, what is the difference between the Exports(as % of merchandise exports) in Fragile and conflict affected situations and Exports(as % of merchandise exports) in Belgium?
Your answer should be compact. 68.76. In the year 2007, what is the difference between the Exports(as % of merchandise exports) in Fragile and conflict affected situations and Exports(as % of merchandise exports) in Fiji?
Your answer should be very brief. 75.69. In the year 2007, what is the difference between the Exports(as % of merchandise exports) in Fragile and conflict affected situations and Exports(as % of merchandise exports) in Nigeria?
Keep it short and to the point. -17.9. In the year 2007, what is the difference between the Exports(as % of merchandise exports) of Belgium and Exports(as % of merchandise exports) of Fiji?
Provide a succinct answer. 6.93. In the year 2007, what is the difference between the Exports(as % of merchandise exports) in Belgium and Exports(as % of merchandise exports) in Nigeria?
Offer a terse response. -86.66. In the year 2007, what is the difference between the Exports(as % of merchandise exports) of Fiji and Exports(as % of merchandise exports) of Nigeria?
Provide a short and direct response. -93.59. In the year 2008, what is the difference between the Exports(as % of merchandise exports) in Fragile and conflict affected situations and Exports(as % of merchandise exports) in Belgium?
Make the answer very short. 50.77. In the year 2008, what is the difference between the Exports(as % of merchandise exports) in Fragile and conflict affected situations and Exports(as % of merchandise exports) in Fiji?
Keep it short and to the point. 59.93. In the year 2008, what is the difference between the Exports(as % of merchandise exports) of Fragile and conflict affected situations and Exports(as % of merchandise exports) of Nigeria?
Your answer should be very brief. -31.77. In the year 2008, what is the difference between the Exports(as % of merchandise exports) in Belgium and Exports(as % of merchandise exports) in Fiji?
Provide a short and direct response. 9.15. In the year 2008, what is the difference between the Exports(as % of merchandise exports) in Belgium and Exports(as % of merchandise exports) in Nigeria?
Keep it short and to the point. -82.54. In the year 2008, what is the difference between the Exports(as % of merchandise exports) of Fiji and Exports(as % of merchandise exports) of Nigeria?
Provide a succinct answer. -91.69. In the year 2009, what is the difference between the Exports(as % of merchandise exports) in Fragile and conflict affected situations and Exports(as % of merchandise exports) in Belgium?
Provide a succinct answer. 69.89. In the year 2009, what is the difference between the Exports(as % of merchandise exports) of Fragile and conflict affected situations and Exports(as % of merchandise exports) of Fiji?
Your answer should be compact. 77.17. In the year 2009, what is the difference between the Exports(as % of merchandise exports) in Fragile and conflict affected situations and Exports(as % of merchandise exports) in Nigeria?
Ensure brevity in your answer.  -13.01. In the year 2009, what is the difference between the Exports(as % of merchandise exports) of Belgium and Exports(as % of merchandise exports) of Fiji?
Give a very brief answer. 7.28. In the year 2009, what is the difference between the Exports(as % of merchandise exports) in Belgium and Exports(as % of merchandise exports) in Nigeria?
Your response must be concise. -82.9. In the year 2009, what is the difference between the Exports(as % of merchandise exports) of Fiji and Exports(as % of merchandise exports) of Nigeria?
Offer a terse response. -90.19. In the year 2010, what is the difference between the Exports(as % of merchandise exports) in Fragile and conflict affected situations and Exports(as % of merchandise exports) in Belgium?
Give a very brief answer. 67.06. In the year 2010, what is the difference between the Exports(as % of merchandise exports) of Fragile and conflict affected situations and Exports(as % of merchandise exports) of Fiji?
Your answer should be very brief. 75.75. In the year 2010, what is the difference between the Exports(as % of merchandise exports) of Fragile and conflict affected situations and Exports(as % of merchandise exports) of Nigeria?
Provide a succinct answer. -11.28. In the year 2010, what is the difference between the Exports(as % of merchandise exports) in Belgium and Exports(as % of merchandise exports) in Fiji?
Your response must be concise. 8.69. In the year 2010, what is the difference between the Exports(as % of merchandise exports) of Belgium and Exports(as % of merchandise exports) of Nigeria?
Give a very brief answer. -78.34. In the year 2010, what is the difference between the Exports(as % of merchandise exports) in Fiji and Exports(as % of merchandise exports) in Nigeria?
Provide a short and direct response. -87.03. What is the ratio of the Exports(as % of merchandise exports) of Fragile and conflict affected situations in 1974 to that in 1975?
Your response must be concise. 0.9. What is the ratio of the Exports(as % of merchandise exports) in Belgium in 1974 to that in 1975?
Provide a short and direct response. 0.69. What is the ratio of the Exports(as % of merchandise exports) in Fiji in 1974 to that in 1975?
Your response must be concise. 15.74. What is the ratio of the Exports(as % of merchandise exports) in Fragile and conflict affected situations in 1974 to that in 1976?
Provide a succinct answer. 0.87. What is the ratio of the Exports(as % of merchandise exports) of Belgium in 1974 to that in 1976?
Keep it short and to the point. 0.7. What is the ratio of the Exports(as % of merchandise exports) in Fiji in 1974 to that in 1976?
Your answer should be compact. 1.31. What is the ratio of the Exports(as % of merchandise exports) of Nigeria in 1974 to that in 1976?
Your answer should be compact. 0.99. What is the ratio of the Exports(as % of merchandise exports) in Fragile and conflict affected situations in 1974 to that in 2007?
Offer a terse response. 0.62. What is the ratio of the Exports(as % of merchandise exports) of Belgium in 1974 to that in 2007?
Make the answer very short. 0.48. What is the ratio of the Exports(as % of merchandise exports) in Fiji in 1974 to that in 2007?
Keep it short and to the point. 0.01. What is the ratio of the Exports(as % of merchandise exports) of Fragile and conflict affected situations in 1974 to that in 2008?
Provide a succinct answer. 0.78. What is the ratio of the Exports(as % of merchandise exports) of Belgium in 1974 to that in 2008?
Give a very brief answer. 0.36. What is the ratio of the Exports(as % of merchandise exports) in Fiji in 1974 to that in 2008?
Your answer should be very brief. 0.01. What is the ratio of the Exports(as % of merchandise exports) of Nigeria in 1974 to that in 2008?
Give a very brief answer. 1.01. What is the ratio of the Exports(as % of merchandise exports) of Fragile and conflict affected situations in 1974 to that in 2009?
Make the answer very short. 0.61. What is the ratio of the Exports(as % of merchandise exports) of Belgium in 1974 to that in 2009?
Keep it short and to the point. 0.45. What is the ratio of the Exports(as % of merchandise exports) of Fiji in 1974 to that in 2009?
Offer a terse response. 0. What is the ratio of the Exports(as % of merchandise exports) in Nigeria in 1974 to that in 2009?
Offer a terse response. 1.03. What is the ratio of the Exports(as % of merchandise exports) of Fragile and conflict affected situations in 1974 to that in 2010?
Your response must be concise. 0.62. What is the ratio of the Exports(as % of merchandise exports) in Belgium in 1974 to that in 2010?
Your response must be concise. 0.38. What is the ratio of the Exports(as % of merchandise exports) in Fiji in 1974 to that in 2010?
Ensure brevity in your answer.  0.01. What is the ratio of the Exports(as % of merchandise exports) in Nigeria in 1974 to that in 2010?
Your answer should be very brief. 1.07. What is the ratio of the Exports(as % of merchandise exports) in Fragile and conflict affected situations in 1975 to that in 1976?
Provide a short and direct response. 0.97. What is the ratio of the Exports(as % of merchandise exports) in Belgium in 1975 to that in 1976?
Offer a terse response. 1.01. What is the ratio of the Exports(as % of merchandise exports) in Fiji in 1975 to that in 1976?
Provide a succinct answer. 0.08. What is the ratio of the Exports(as % of merchandise exports) of Nigeria in 1975 to that in 1976?
Provide a short and direct response. 0.99. What is the ratio of the Exports(as % of merchandise exports) of Fragile and conflict affected situations in 1975 to that in 2007?
Provide a succinct answer. 0.69. What is the ratio of the Exports(as % of merchandise exports) of Belgium in 1975 to that in 2007?
Keep it short and to the point. 0.69. What is the ratio of the Exports(as % of merchandise exports) of Fiji in 1975 to that in 2007?
Provide a succinct answer. 0. What is the ratio of the Exports(as % of merchandise exports) in Nigeria in 1975 to that in 2007?
Your answer should be very brief. 1. What is the ratio of the Exports(as % of merchandise exports) of Fragile and conflict affected situations in 1975 to that in 2008?
Provide a short and direct response. 0.87. What is the ratio of the Exports(as % of merchandise exports) in Belgium in 1975 to that in 2008?
Ensure brevity in your answer.  0.53. What is the ratio of the Exports(as % of merchandise exports) in Fiji in 1975 to that in 2008?
Your answer should be very brief. 0. What is the ratio of the Exports(as % of merchandise exports) of Fragile and conflict affected situations in 1975 to that in 2009?
Keep it short and to the point. 0.67. What is the ratio of the Exports(as % of merchandise exports) of Belgium in 1975 to that in 2009?
Provide a succinct answer. 0.65. What is the ratio of the Exports(as % of merchandise exports) in Fiji in 1975 to that in 2009?
Offer a terse response. 0. What is the ratio of the Exports(as % of merchandise exports) of Nigeria in 1975 to that in 2009?
Offer a terse response. 1.03. What is the ratio of the Exports(as % of merchandise exports) of Fragile and conflict affected situations in 1975 to that in 2010?
Give a very brief answer. 0.69. What is the ratio of the Exports(as % of merchandise exports) of Belgium in 1975 to that in 2010?
Provide a short and direct response. 0.55. What is the ratio of the Exports(as % of merchandise exports) of Fiji in 1975 to that in 2010?
Ensure brevity in your answer.  0. What is the ratio of the Exports(as % of merchandise exports) of Nigeria in 1975 to that in 2010?
Your answer should be compact. 1.07. What is the ratio of the Exports(as % of merchandise exports) of Fragile and conflict affected situations in 1976 to that in 2007?
Offer a terse response. 0.71. What is the ratio of the Exports(as % of merchandise exports) of Belgium in 1976 to that in 2007?
Your response must be concise. 0.68. What is the ratio of the Exports(as % of merchandise exports) in Fiji in 1976 to that in 2007?
Ensure brevity in your answer.  0.01. What is the ratio of the Exports(as % of merchandise exports) of Nigeria in 1976 to that in 2007?
Offer a very short reply. 1.01. What is the ratio of the Exports(as % of merchandise exports) in Fragile and conflict affected situations in 1976 to that in 2008?
Give a very brief answer. 0.9. What is the ratio of the Exports(as % of merchandise exports) of Belgium in 1976 to that in 2008?
Keep it short and to the point. 0.52. What is the ratio of the Exports(as % of merchandise exports) in Fiji in 1976 to that in 2008?
Your answer should be compact. 0.01. What is the ratio of the Exports(as % of merchandise exports) in Nigeria in 1976 to that in 2008?
Ensure brevity in your answer.  1.03. What is the ratio of the Exports(as % of merchandise exports) of Fragile and conflict affected situations in 1976 to that in 2009?
Provide a short and direct response. 0.7. What is the ratio of the Exports(as % of merchandise exports) in Belgium in 1976 to that in 2009?
Offer a very short reply. 0.64. What is the ratio of the Exports(as % of merchandise exports) of Fiji in 1976 to that in 2009?
Your answer should be compact. 0. What is the ratio of the Exports(as % of merchandise exports) of Nigeria in 1976 to that in 2009?
Offer a terse response. 1.04. What is the ratio of the Exports(as % of merchandise exports) of Fragile and conflict affected situations in 1976 to that in 2010?
Offer a very short reply. 0.71. What is the ratio of the Exports(as % of merchandise exports) in Belgium in 1976 to that in 2010?
Your answer should be compact. 0.55. What is the ratio of the Exports(as % of merchandise exports) in Fiji in 1976 to that in 2010?
Make the answer very short. 0.01. What is the ratio of the Exports(as % of merchandise exports) of Nigeria in 1976 to that in 2010?
Your answer should be compact. 1.08. What is the ratio of the Exports(as % of merchandise exports) in Fragile and conflict affected situations in 2007 to that in 2008?
Provide a succinct answer. 1.26. What is the ratio of the Exports(as % of merchandise exports) in Belgium in 2007 to that in 2008?
Offer a very short reply. 0.76. What is the ratio of the Exports(as % of merchandise exports) in Fiji in 2007 to that in 2008?
Offer a terse response. 1.55. What is the ratio of the Exports(as % of merchandise exports) in Nigeria in 2007 to that in 2008?
Ensure brevity in your answer.  1.02. What is the ratio of the Exports(as % of merchandise exports) of Fragile and conflict affected situations in 2007 to that in 2009?
Your answer should be very brief. 0.98. What is the ratio of the Exports(as % of merchandise exports) of Belgium in 2007 to that in 2009?
Provide a short and direct response. 0.94. What is the ratio of the Exports(as % of merchandise exports) in Fiji in 2007 to that in 2009?
Keep it short and to the point. 0.43. What is the ratio of the Exports(as % of merchandise exports) in Nigeria in 2007 to that in 2009?
Keep it short and to the point. 1.04. What is the ratio of the Exports(as % of merchandise exports) of Fragile and conflict affected situations in 2007 to that in 2010?
Provide a short and direct response. 1. What is the ratio of the Exports(as % of merchandise exports) of Belgium in 2007 to that in 2010?
Provide a short and direct response. 0.8. What is the ratio of the Exports(as % of merchandise exports) of Fiji in 2007 to that in 2010?
Make the answer very short. 0.77. What is the ratio of the Exports(as % of merchandise exports) in Nigeria in 2007 to that in 2010?
Your response must be concise. 1.07. What is the ratio of the Exports(as % of merchandise exports) in Fragile and conflict affected situations in 2008 to that in 2009?
Give a very brief answer. 0.78. What is the ratio of the Exports(as % of merchandise exports) of Belgium in 2008 to that in 2009?
Provide a succinct answer. 1.23. What is the ratio of the Exports(as % of merchandise exports) of Fiji in 2008 to that in 2009?
Offer a very short reply. 0.28. What is the ratio of the Exports(as % of merchandise exports) in Nigeria in 2008 to that in 2009?
Ensure brevity in your answer.  1.02. What is the ratio of the Exports(as % of merchandise exports) in Fragile and conflict affected situations in 2008 to that in 2010?
Provide a short and direct response. 0.79. What is the ratio of the Exports(as % of merchandise exports) of Belgium in 2008 to that in 2010?
Your answer should be very brief. 1.05. What is the ratio of the Exports(as % of merchandise exports) of Fiji in 2008 to that in 2010?
Provide a short and direct response. 0.5. What is the ratio of the Exports(as % of merchandise exports) in Nigeria in 2008 to that in 2010?
Provide a succinct answer. 1.05. What is the ratio of the Exports(as % of merchandise exports) in Fragile and conflict affected situations in 2009 to that in 2010?
Offer a terse response. 1.02. What is the ratio of the Exports(as % of merchandise exports) in Belgium in 2009 to that in 2010?
Make the answer very short. 0.85. What is the ratio of the Exports(as % of merchandise exports) in Fiji in 2009 to that in 2010?
Ensure brevity in your answer.  1.79. What is the ratio of the Exports(as % of merchandise exports) of Nigeria in 2009 to that in 2010?
Your answer should be very brief. 1.04. What is the difference between the highest and the second highest Exports(as % of merchandise exports) of Fragile and conflict affected situations?
Keep it short and to the point. 1.5. What is the difference between the highest and the second highest Exports(as % of merchandise exports) of Belgium?
Keep it short and to the point. 0.41. What is the difference between the highest and the second highest Exports(as % of merchandise exports) in Fiji?
Provide a short and direct response. 0.08. What is the difference between the highest and the second highest Exports(as % of merchandise exports) of Nigeria?
Your response must be concise. 0.65. What is the difference between the highest and the lowest Exports(as % of merchandise exports) of Fragile and conflict affected situations?
Keep it short and to the point. 30.41. What is the difference between the highest and the lowest Exports(as % of merchandise exports) in Belgium?
Make the answer very short. 5.87. What is the difference between the highest and the lowest Exports(as % of merchandise exports) of Fiji?
Your response must be concise. 0.18. What is the difference between the highest and the lowest Exports(as % of merchandise exports) in Nigeria?
Your answer should be compact. 7.18. 